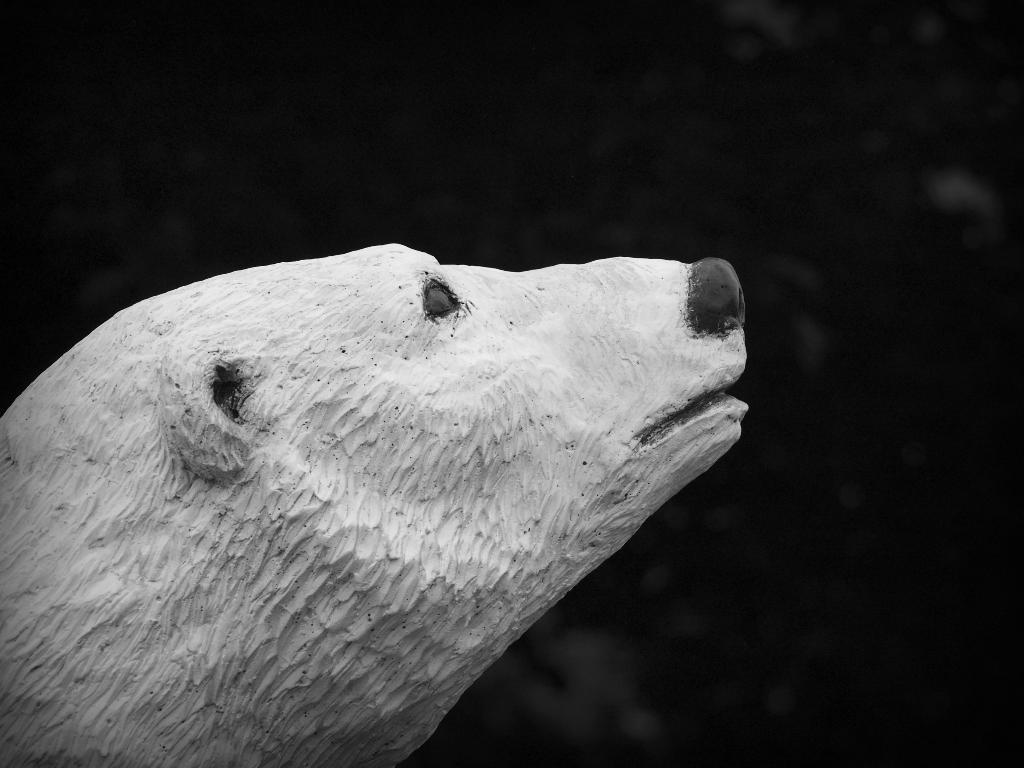How would you summarize this image in a sentence or two? In this image I can see statue of an animal. And there is a dark background. 